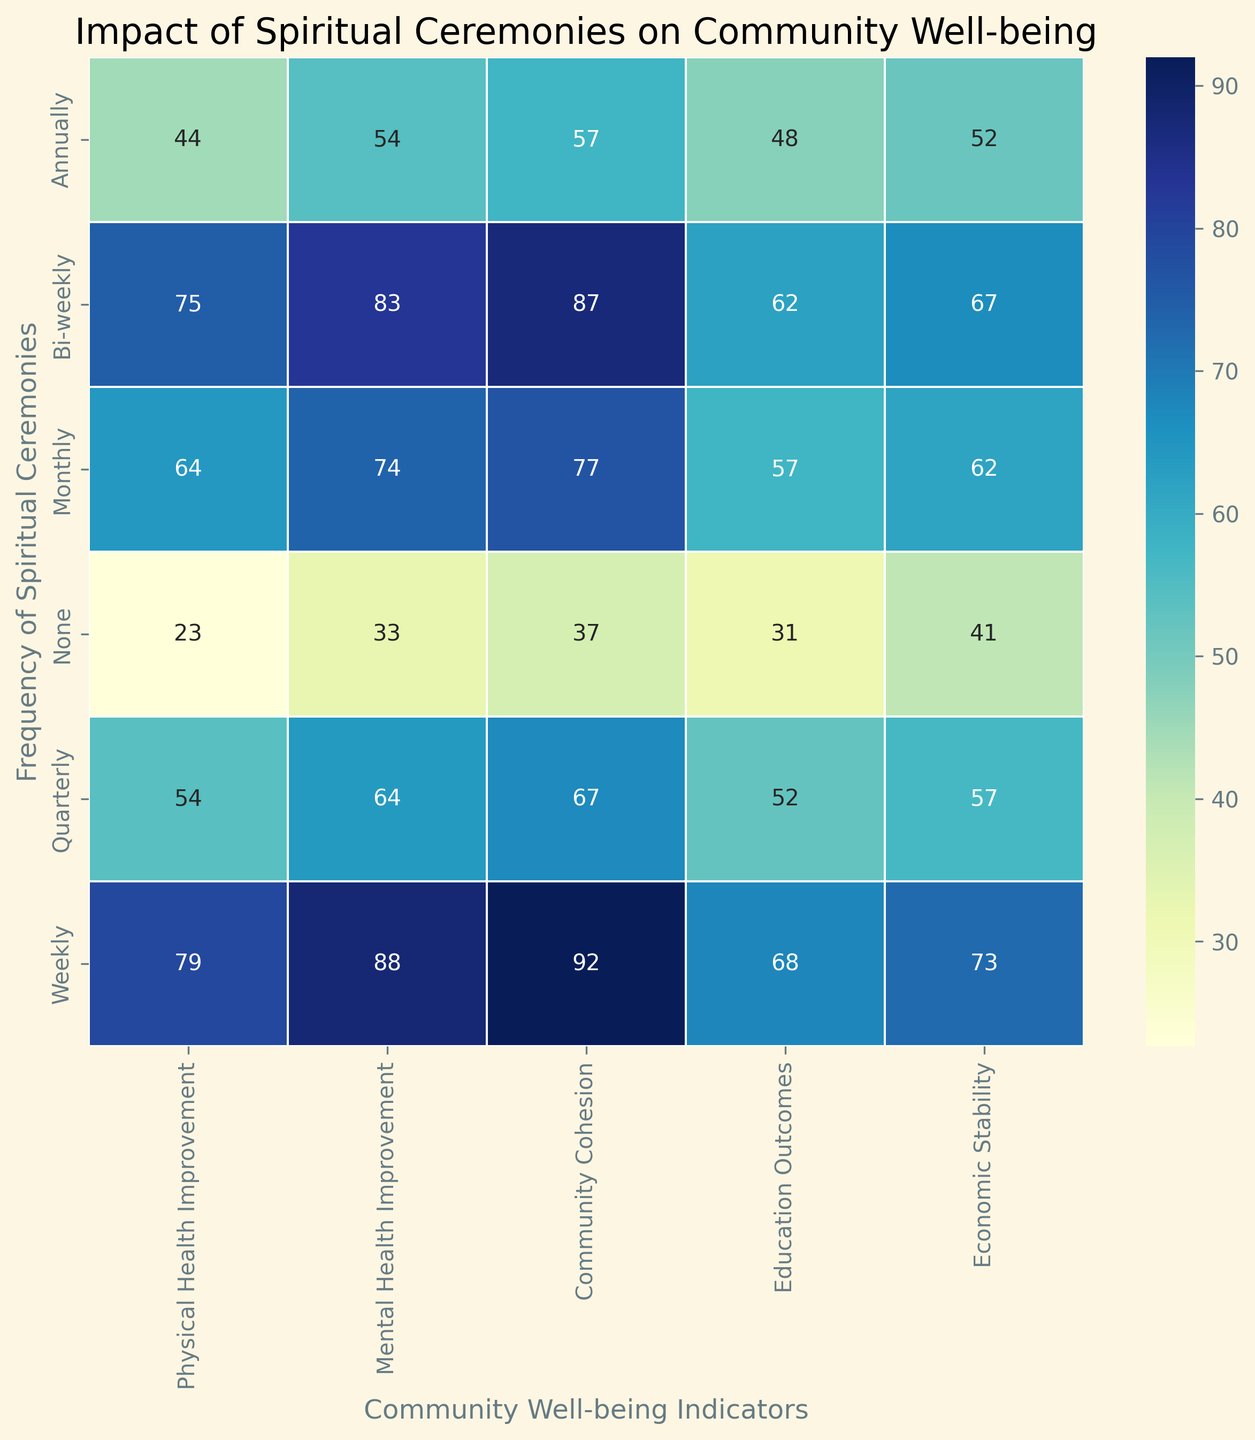What is the impact on physical health improvement when spiritual ceremonies are held weekly versus annually? To find the impact on physical health improvement for weekly ceremonies, look at the intersection of the "Weekly" row and the "Physical Health Improvement" column. Similarly, find the value for the "Annually" row and the same column. Compare these two values. For weekly, the value is higher (average around 79 to 82), while for annually, it is around 44 to 48.
Answer: Weekly ceremonies have much higher physical health improvement In terms of community cohesion, how do bi-weekly ceremonies compare to monthly ceremonies? Locate the "Bi-weekly" and "Monthly" rows and find the corresponding values under the "Community Cohesion" column. The community cohesion values for bi-weekly are around 87 to 89 and for monthly are around 76 to 78.
Answer: Bi-weekly ceremonies have higher community cohesion Which frequency of ceremonies shows the highest mental health improvement? Find the highest value in the column for "Mental Health Improvement." Look at the frequency of ceremonies associated with this highest value. The "Weekly" category has the highest values, approximately in the range of 88 to 90.
Answer: Weekly ceremonies What is the average economic stability improvement for monthly ceremonies? Locate the "Monthly" row and find the values under the "Economic Stability" column. Average these values: (60 + 62 + 63) / 3 = 61.67.
Answer: Approximately 61.67 Compare the highest and lowest physical health improvement values from all categories. Identify the highest value and the lowest value in the "Physical Health Improvement" column. The highest value is around 82 (Weekly), and the lowest value is around 20 to 23 (None).
Answer: 82 (highest) and 20 to 23 (lowest) If the frequency of spiritual ceremonies is increased from quarterly to bi-weekly, how would economic stability change? Look at the values under the "Economic Stability" column for "Quarterly" and "Bi-weekly." Compare the respective values, which are approximately 55 to 58 for quarterly and 65 to 68 for bi-weekly.
Answer: Economic stability increases significantly By how much does community cohesion improve when moving from annual to weekly ceremonies? Locate the "Annually" and "Weekly" rows in the "Community Cohesion" column. Subtract the values for "Annually" from the values for "Weekly." Community cohesion for annually is around 50 to 55, and for weekly is around 90 to 94. The improvement is therefore (90-55) to (94-50), approximately 35 to 44.
Answer: Approximately 35 to 44 points What is the median value for education outcomes across all frequencies? Collect all values under the "Education Outcomes" column and arrange them in ascending order: [30, 31, 32, 45, 48, 50, 53, 55, 57, 58, 59, 60, 62, 63, 64, 65, 67, 68, 70, 73]. The median value is the average of the 10th and 11th values: (57 + 58) / 2 = 57.5.
Answer: 57.5 